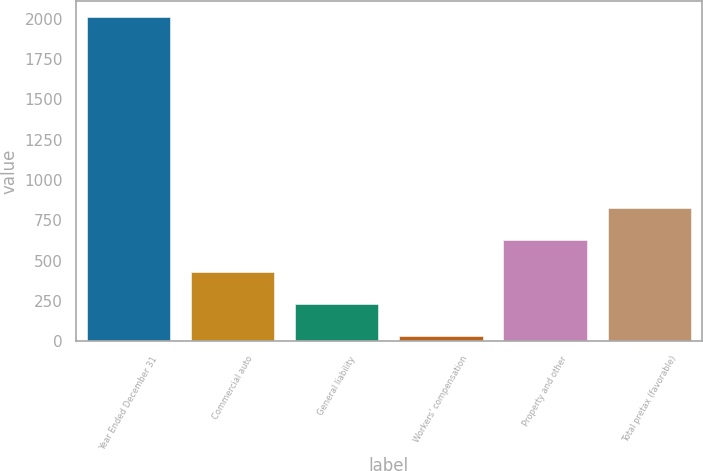Convert chart to OTSL. <chart><loc_0><loc_0><loc_500><loc_500><bar_chart><fcel>Year Ended December 31<fcel>Commercial auto<fcel>General liability<fcel>Workers' compensation<fcel>Property and other<fcel>Total pretax (favorable)<nl><fcel>2011<fcel>431<fcel>233.5<fcel>36<fcel>628.5<fcel>826<nl></chart> 